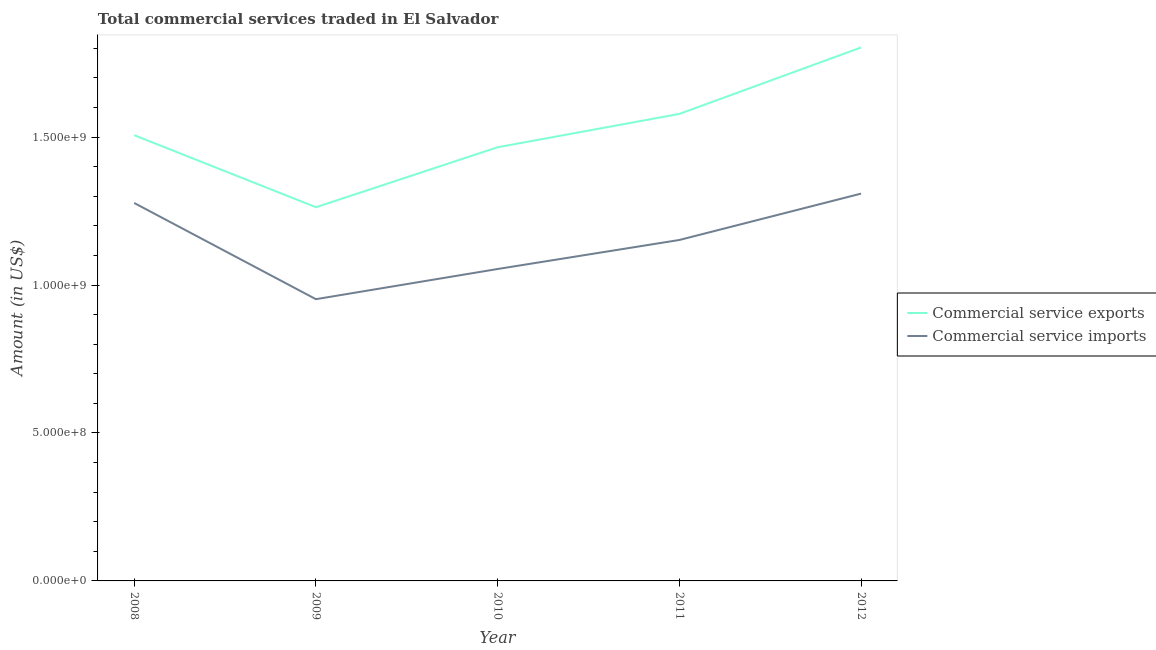What is the amount of commercial service exports in 2010?
Provide a succinct answer. 1.47e+09. Across all years, what is the maximum amount of commercial service imports?
Your response must be concise. 1.31e+09. Across all years, what is the minimum amount of commercial service exports?
Ensure brevity in your answer.  1.26e+09. In which year was the amount of commercial service imports maximum?
Keep it short and to the point. 2012. In which year was the amount of commercial service imports minimum?
Keep it short and to the point. 2009. What is the total amount of commercial service imports in the graph?
Your answer should be very brief. 5.75e+09. What is the difference between the amount of commercial service exports in 2009 and that in 2012?
Give a very brief answer. -5.40e+08. What is the difference between the amount of commercial service exports in 2008 and the amount of commercial service imports in 2009?
Make the answer very short. 5.54e+08. What is the average amount of commercial service exports per year?
Make the answer very short. 1.52e+09. In the year 2010, what is the difference between the amount of commercial service exports and amount of commercial service imports?
Make the answer very short. 4.12e+08. In how many years, is the amount of commercial service exports greater than 1200000000 US$?
Ensure brevity in your answer.  5. What is the ratio of the amount of commercial service imports in 2009 to that in 2011?
Ensure brevity in your answer.  0.83. Is the amount of commercial service exports in 2008 less than that in 2012?
Make the answer very short. Yes. What is the difference between the highest and the second highest amount of commercial service exports?
Make the answer very short. 2.25e+08. What is the difference between the highest and the lowest amount of commercial service exports?
Provide a short and direct response. 5.40e+08. Is the amount of commercial service imports strictly less than the amount of commercial service exports over the years?
Make the answer very short. Yes. Are the values on the major ticks of Y-axis written in scientific E-notation?
Provide a succinct answer. Yes. Does the graph contain any zero values?
Your response must be concise. No. Does the graph contain grids?
Offer a terse response. No. Where does the legend appear in the graph?
Keep it short and to the point. Center right. How are the legend labels stacked?
Provide a short and direct response. Vertical. What is the title of the graph?
Provide a short and direct response. Total commercial services traded in El Salvador. Does "Private consumption" appear as one of the legend labels in the graph?
Provide a short and direct response. No. What is the label or title of the X-axis?
Offer a terse response. Year. What is the Amount (in US$) of Commercial service exports in 2008?
Your answer should be very brief. 1.51e+09. What is the Amount (in US$) in Commercial service imports in 2008?
Make the answer very short. 1.28e+09. What is the Amount (in US$) in Commercial service exports in 2009?
Provide a succinct answer. 1.26e+09. What is the Amount (in US$) of Commercial service imports in 2009?
Provide a succinct answer. 9.52e+08. What is the Amount (in US$) in Commercial service exports in 2010?
Provide a short and direct response. 1.47e+09. What is the Amount (in US$) of Commercial service imports in 2010?
Your answer should be compact. 1.05e+09. What is the Amount (in US$) of Commercial service exports in 2011?
Provide a succinct answer. 1.58e+09. What is the Amount (in US$) of Commercial service imports in 2011?
Provide a short and direct response. 1.15e+09. What is the Amount (in US$) of Commercial service exports in 2012?
Offer a terse response. 1.80e+09. What is the Amount (in US$) of Commercial service imports in 2012?
Keep it short and to the point. 1.31e+09. Across all years, what is the maximum Amount (in US$) in Commercial service exports?
Give a very brief answer. 1.80e+09. Across all years, what is the maximum Amount (in US$) of Commercial service imports?
Provide a short and direct response. 1.31e+09. Across all years, what is the minimum Amount (in US$) in Commercial service exports?
Give a very brief answer. 1.26e+09. Across all years, what is the minimum Amount (in US$) in Commercial service imports?
Your response must be concise. 9.52e+08. What is the total Amount (in US$) of Commercial service exports in the graph?
Your answer should be compact. 7.62e+09. What is the total Amount (in US$) in Commercial service imports in the graph?
Ensure brevity in your answer.  5.75e+09. What is the difference between the Amount (in US$) in Commercial service exports in 2008 and that in 2009?
Your answer should be compact. 2.43e+08. What is the difference between the Amount (in US$) in Commercial service imports in 2008 and that in 2009?
Make the answer very short. 3.25e+08. What is the difference between the Amount (in US$) in Commercial service exports in 2008 and that in 2010?
Offer a terse response. 4.06e+07. What is the difference between the Amount (in US$) of Commercial service imports in 2008 and that in 2010?
Make the answer very short. 2.23e+08. What is the difference between the Amount (in US$) of Commercial service exports in 2008 and that in 2011?
Keep it short and to the point. -7.20e+07. What is the difference between the Amount (in US$) in Commercial service imports in 2008 and that in 2011?
Make the answer very short. 1.25e+08. What is the difference between the Amount (in US$) of Commercial service exports in 2008 and that in 2012?
Provide a short and direct response. -2.97e+08. What is the difference between the Amount (in US$) of Commercial service imports in 2008 and that in 2012?
Make the answer very short. -3.16e+07. What is the difference between the Amount (in US$) of Commercial service exports in 2009 and that in 2010?
Give a very brief answer. -2.03e+08. What is the difference between the Amount (in US$) in Commercial service imports in 2009 and that in 2010?
Provide a succinct answer. -1.02e+08. What is the difference between the Amount (in US$) of Commercial service exports in 2009 and that in 2011?
Provide a succinct answer. -3.15e+08. What is the difference between the Amount (in US$) in Commercial service imports in 2009 and that in 2011?
Your response must be concise. -2.00e+08. What is the difference between the Amount (in US$) of Commercial service exports in 2009 and that in 2012?
Give a very brief answer. -5.40e+08. What is the difference between the Amount (in US$) of Commercial service imports in 2009 and that in 2012?
Make the answer very short. -3.57e+08. What is the difference between the Amount (in US$) of Commercial service exports in 2010 and that in 2011?
Give a very brief answer. -1.13e+08. What is the difference between the Amount (in US$) in Commercial service imports in 2010 and that in 2011?
Provide a succinct answer. -9.80e+07. What is the difference between the Amount (in US$) of Commercial service exports in 2010 and that in 2012?
Make the answer very short. -3.37e+08. What is the difference between the Amount (in US$) in Commercial service imports in 2010 and that in 2012?
Make the answer very short. -2.55e+08. What is the difference between the Amount (in US$) in Commercial service exports in 2011 and that in 2012?
Give a very brief answer. -2.25e+08. What is the difference between the Amount (in US$) of Commercial service imports in 2011 and that in 2012?
Ensure brevity in your answer.  -1.57e+08. What is the difference between the Amount (in US$) of Commercial service exports in 2008 and the Amount (in US$) of Commercial service imports in 2009?
Give a very brief answer. 5.54e+08. What is the difference between the Amount (in US$) in Commercial service exports in 2008 and the Amount (in US$) in Commercial service imports in 2010?
Offer a very short reply. 4.52e+08. What is the difference between the Amount (in US$) of Commercial service exports in 2008 and the Amount (in US$) of Commercial service imports in 2011?
Your answer should be very brief. 3.54e+08. What is the difference between the Amount (in US$) of Commercial service exports in 2008 and the Amount (in US$) of Commercial service imports in 2012?
Your answer should be compact. 1.97e+08. What is the difference between the Amount (in US$) of Commercial service exports in 2009 and the Amount (in US$) of Commercial service imports in 2010?
Your response must be concise. 2.09e+08. What is the difference between the Amount (in US$) in Commercial service exports in 2009 and the Amount (in US$) in Commercial service imports in 2011?
Your answer should be compact. 1.11e+08. What is the difference between the Amount (in US$) of Commercial service exports in 2009 and the Amount (in US$) of Commercial service imports in 2012?
Give a very brief answer. -4.59e+07. What is the difference between the Amount (in US$) in Commercial service exports in 2010 and the Amount (in US$) in Commercial service imports in 2011?
Your answer should be compact. 3.13e+08. What is the difference between the Amount (in US$) in Commercial service exports in 2010 and the Amount (in US$) in Commercial service imports in 2012?
Make the answer very short. 1.57e+08. What is the difference between the Amount (in US$) in Commercial service exports in 2011 and the Amount (in US$) in Commercial service imports in 2012?
Offer a terse response. 2.69e+08. What is the average Amount (in US$) of Commercial service exports per year?
Offer a very short reply. 1.52e+09. What is the average Amount (in US$) of Commercial service imports per year?
Give a very brief answer. 1.15e+09. In the year 2008, what is the difference between the Amount (in US$) of Commercial service exports and Amount (in US$) of Commercial service imports?
Provide a succinct answer. 2.29e+08. In the year 2009, what is the difference between the Amount (in US$) in Commercial service exports and Amount (in US$) in Commercial service imports?
Provide a succinct answer. 3.11e+08. In the year 2010, what is the difference between the Amount (in US$) of Commercial service exports and Amount (in US$) of Commercial service imports?
Make the answer very short. 4.12e+08. In the year 2011, what is the difference between the Amount (in US$) of Commercial service exports and Amount (in US$) of Commercial service imports?
Make the answer very short. 4.26e+08. In the year 2012, what is the difference between the Amount (in US$) in Commercial service exports and Amount (in US$) in Commercial service imports?
Keep it short and to the point. 4.94e+08. What is the ratio of the Amount (in US$) in Commercial service exports in 2008 to that in 2009?
Provide a short and direct response. 1.19. What is the ratio of the Amount (in US$) in Commercial service imports in 2008 to that in 2009?
Give a very brief answer. 1.34. What is the ratio of the Amount (in US$) in Commercial service exports in 2008 to that in 2010?
Your answer should be compact. 1.03. What is the ratio of the Amount (in US$) in Commercial service imports in 2008 to that in 2010?
Offer a very short reply. 1.21. What is the ratio of the Amount (in US$) in Commercial service exports in 2008 to that in 2011?
Your response must be concise. 0.95. What is the ratio of the Amount (in US$) of Commercial service imports in 2008 to that in 2011?
Your response must be concise. 1.11. What is the ratio of the Amount (in US$) in Commercial service exports in 2008 to that in 2012?
Make the answer very short. 0.84. What is the ratio of the Amount (in US$) of Commercial service imports in 2008 to that in 2012?
Keep it short and to the point. 0.98. What is the ratio of the Amount (in US$) in Commercial service exports in 2009 to that in 2010?
Offer a very short reply. 0.86. What is the ratio of the Amount (in US$) of Commercial service imports in 2009 to that in 2010?
Make the answer very short. 0.9. What is the ratio of the Amount (in US$) of Commercial service exports in 2009 to that in 2011?
Your response must be concise. 0.8. What is the ratio of the Amount (in US$) in Commercial service imports in 2009 to that in 2011?
Your answer should be very brief. 0.83. What is the ratio of the Amount (in US$) of Commercial service exports in 2009 to that in 2012?
Make the answer very short. 0.7. What is the ratio of the Amount (in US$) in Commercial service imports in 2009 to that in 2012?
Your response must be concise. 0.73. What is the ratio of the Amount (in US$) in Commercial service exports in 2010 to that in 2011?
Your answer should be compact. 0.93. What is the ratio of the Amount (in US$) in Commercial service imports in 2010 to that in 2011?
Keep it short and to the point. 0.91. What is the ratio of the Amount (in US$) of Commercial service exports in 2010 to that in 2012?
Provide a succinct answer. 0.81. What is the ratio of the Amount (in US$) of Commercial service imports in 2010 to that in 2012?
Provide a succinct answer. 0.81. What is the ratio of the Amount (in US$) in Commercial service exports in 2011 to that in 2012?
Your answer should be compact. 0.88. What is the ratio of the Amount (in US$) in Commercial service imports in 2011 to that in 2012?
Offer a terse response. 0.88. What is the difference between the highest and the second highest Amount (in US$) in Commercial service exports?
Provide a short and direct response. 2.25e+08. What is the difference between the highest and the second highest Amount (in US$) of Commercial service imports?
Ensure brevity in your answer.  3.16e+07. What is the difference between the highest and the lowest Amount (in US$) in Commercial service exports?
Keep it short and to the point. 5.40e+08. What is the difference between the highest and the lowest Amount (in US$) in Commercial service imports?
Provide a short and direct response. 3.57e+08. 